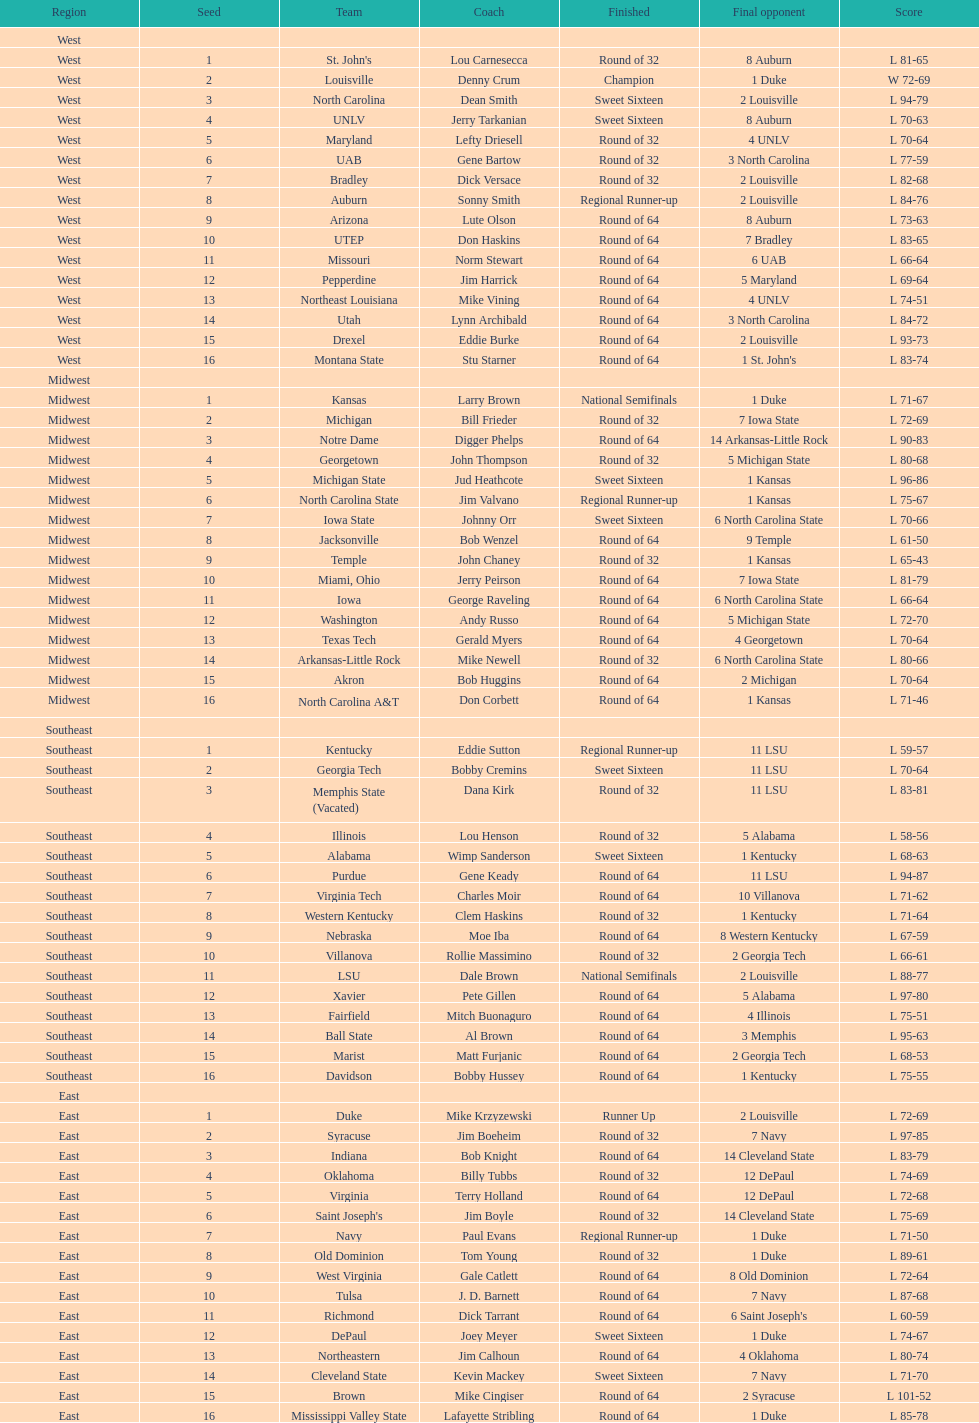What geographical section is stated before the midwest? West. 